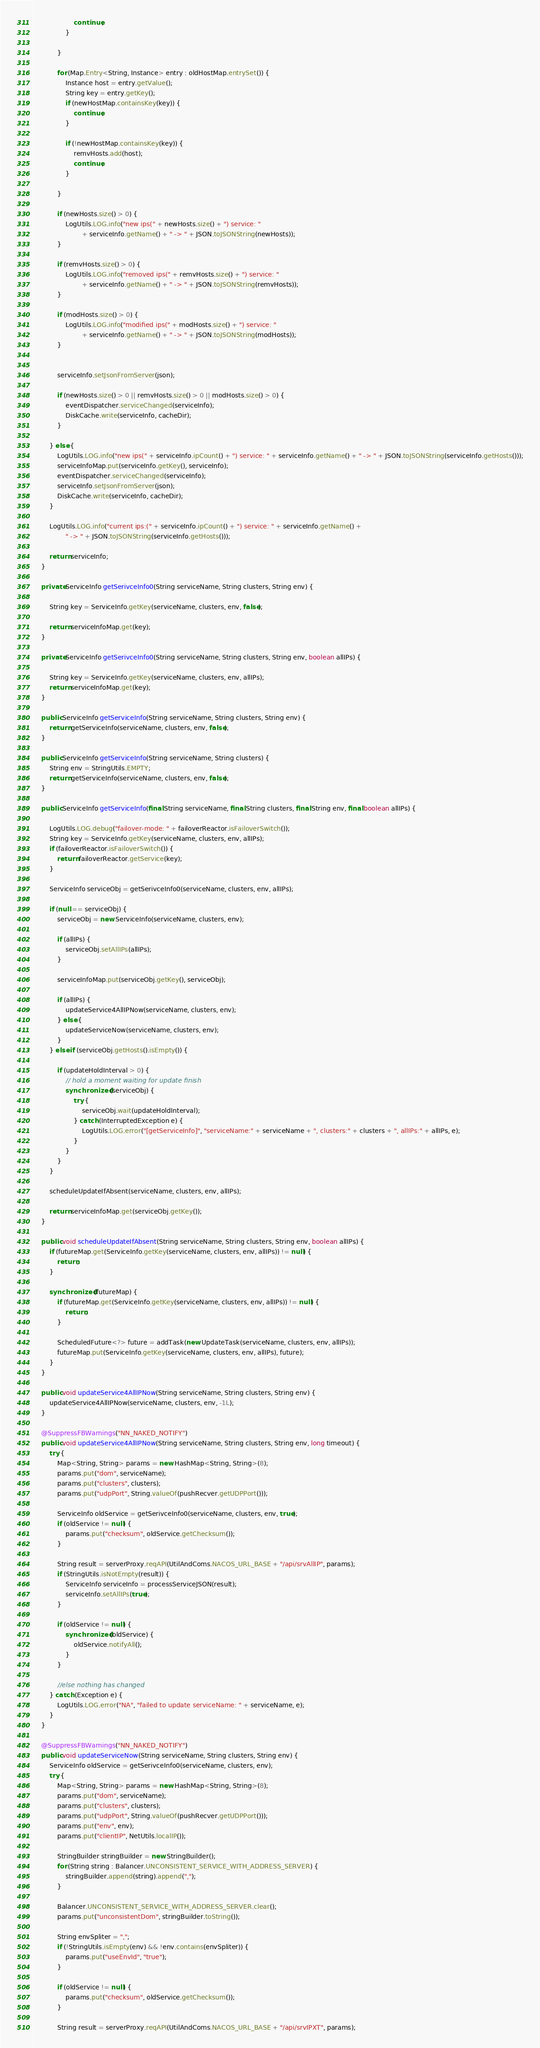Convert code to text. <code><loc_0><loc_0><loc_500><loc_500><_Java_>                    continue;
                }

            }

            for (Map.Entry<String, Instance> entry : oldHostMap.entrySet()) {
                Instance host = entry.getValue();
                String key = entry.getKey();
                if (newHostMap.containsKey(key)) {
                    continue;
                }

                if (!newHostMap.containsKey(key)) {
                    remvHosts.add(host);
                    continue;
                }

            }

            if (newHosts.size() > 0) {
                LogUtils.LOG.info("new ips(" + newHosts.size() + ") service: "
                        + serviceInfo.getName() + " -> " + JSON.toJSONString(newHosts));
            }

            if (remvHosts.size() > 0) {
                LogUtils.LOG.info("removed ips(" + remvHosts.size() + ") service: "
                        + serviceInfo.getName() + " -> " + JSON.toJSONString(remvHosts));
            }

            if (modHosts.size() > 0) {
                LogUtils.LOG.info("modified ips(" + modHosts.size() + ") service: "
                        + serviceInfo.getName() + " -> " + JSON.toJSONString(modHosts));
            }


            serviceInfo.setJsonFromServer(json);

            if (newHosts.size() > 0 || remvHosts.size() > 0 || modHosts.size() > 0) {
                eventDispatcher.serviceChanged(serviceInfo);
                DiskCache.write(serviceInfo, cacheDir);
            }

        } else {
            LogUtils.LOG.info("new ips(" + serviceInfo.ipCount() + ") service: " + serviceInfo.getName() + " -> " + JSON.toJSONString(serviceInfo.getHosts()));
            serviceInfoMap.put(serviceInfo.getKey(), serviceInfo);
            eventDispatcher.serviceChanged(serviceInfo);
            serviceInfo.setJsonFromServer(json);
            DiskCache.write(serviceInfo, cacheDir);
        }

        LogUtils.LOG.info("current ips:(" + serviceInfo.ipCount() + ") service: " + serviceInfo.getName() +
                " -> " + JSON.toJSONString(serviceInfo.getHosts()));

        return serviceInfo;
    }

    private ServiceInfo getSerivceInfo0(String serviceName, String clusters, String env) {

        String key = ServiceInfo.getKey(serviceName, clusters, env, false);

        return serviceInfoMap.get(key);
    }

    private ServiceInfo getSerivceInfo0(String serviceName, String clusters, String env, boolean allIPs) {

        String key = ServiceInfo.getKey(serviceName, clusters, env, allIPs);
        return serviceInfoMap.get(key);
    }

    public ServiceInfo getServiceInfo(String serviceName, String clusters, String env) {
        return getServiceInfo(serviceName, clusters, env, false);
    }

    public ServiceInfo getServiceInfo(String serviceName, String clusters) {
        String env = StringUtils.EMPTY;
        return getServiceInfo(serviceName, clusters, env, false);
    }

    public ServiceInfo getServiceInfo(final String serviceName, final String clusters, final String env, final boolean allIPs) {

        LogUtils.LOG.debug("failover-mode: " + failoverReactor.isFailoverSwitch());
        String key = ServiceInfo.getKey(serviceName, clusters, env, allIPs);
        if (failoverReactor.isFailoverSwitch()) {
            return failoverReactor.getService(key);
        }

        ServiceInfo serviceObj = getSerivceInfo0(serviceName, clusters, env, allIPs);

        if (null == serviceObj) {
            serviceObj = new ServiceInfo(serviceName, clusters, env);

            if (allIPs) {
                serviceObj.setAllIPs(allIPs);
            }

            serviceInfoMap.put(serviceObj.getKey(), serviceObj);

            if (allIPs) {
                updateService4AllIPNow(serviceName, clusters, env);
            } else {
                updateServiceNow(serviceName, clusters, env);
            }
        } else if (serviceObj.getHosts().isEmpty()) {

            if (updateHoldInterval > 0) {
                // hold a moment waiting for update finish
                synchronized (serviceObj) {
                    try {
                        serviceObj.wait(updateHoldInterval);
                    } catch (InterruptedException e) {
                        LogUtils.LOG.error("[getServiceInfo]", "serviceName:" + serviceName + ", clusters:" + clusters + ", allIPs:" + allIPs, e);
                    }
                }
            }
        }

        scheduleUpdateIfAbsent(serviceName, clusters, env, allIPs);

        return serviceInfoMap.get(serviceObj.getKey());
    }

    public void scheduleUpdateIfAbsent(String serviceName, String clusters, String env, boolean allIPs) {
        if (futureMap.get(ServiceInfo.getKey(serviceName, clusters, env, allIPs)) != null) {
            return;
        }

        synchronized (futureMap) {
            if (futureMap.get(ServiceInfo.getKey(serviceName, clusters, env, allIPs)) != null) {
                return;
            }

            ScheduledFuture<?> future = addTask(new UpdateTask(serviceName, clusters, env, allIPs));
            futureMap.put(ServiceInfo.getKey(serviceName, clusters, env, allIPs), future);
        }
    }

    public void updateService4AllIPNow(String serviceName, String clusters, String env) {
        updateService4AllIPNow(serviceName, clusters, env, -1L);
    }

    @SuppressFBWarnings("NN_NAKED_NOTIFY")
    public void updateService4AllIPNow(String serviceName, String clusters, String env, long timeout) {
        try {
            Map<String, String> params = new HashMap<String, String>(8);
            params.put("dom", serviceName);
            params.put("clusters", clusters);
            params.put("udpPort", String.valueOf(pushRecver.getUDPPort()));

            ServiceInfo oldService = getSerivceInfo0(serviceName, clusters, env, true);
            if (oldService != null) {
                params.put("checksum", oldService.getChecksum());
            }

            String result = serverProxy.reqAPI(UtilAndComs.NACOS_URL_BASE + "/api/srvAllIP", params);
            if (StringUtils.isNotEmpty(result)) {
                ServiceInfo serviceInfo = processServiceJSON(result);
                serviceInfo.setAllIPs(true);
            }

            if (oldService != null) {
                synchronized (oldService) {
                    oldService.notifyAll();
                }
            }

            //else nothing has changed
        } catch (Exception e) {
            LogUtils.LOG.error("NA", "failed to update serviceName: " + serviceName, e);
        }
    }

    @SuppressFBWarnings("NN_NAKED_NOTIFY")
    public void updateServiceNow(String serviceName, String clusters, String env) {
        ServiceInfo oldService = getSerivceInfo0(serviceName, clusters, env);
        try {
            Map<String, String> params = new HashMap<String, String>(8);
            params.put("dom", serviceName);
            params.put("clusters", clusters);
            params.put("udpPort", String.valueOf(pushRecver.getUDPPort()));
            params.put("env", env);
            params.put("clientIP", NetUtils.localIP());

            StringBuilder stringBuilder = new StringBuilder();
            for (String string : Balancer.UNCONSISTENT_SERVICE_WITH_ADDRESS_SERVER) {
                stringBuilder.append(string).append(",");
            }

            Balancer.UNCONSISTENT_SERVICE_WITH_ADDRESS_SERVER.clear();
            params.put("unconsistentDom", stringBuilder.toString());

            String envSpliter = ",";
            if (!StringUtils.isEmpty(env) && !env.contains(envSpliter)) {
                params.put("useEnvId", "true");
            }

            if (oldService != null) {
                params.put("checksum", oldService.getChecksum());
            }

            String result = serverProxy.reqAPI(UtilAndComs.NACOS_URL_BASE + "/api/srvIPXT", params);</code> 